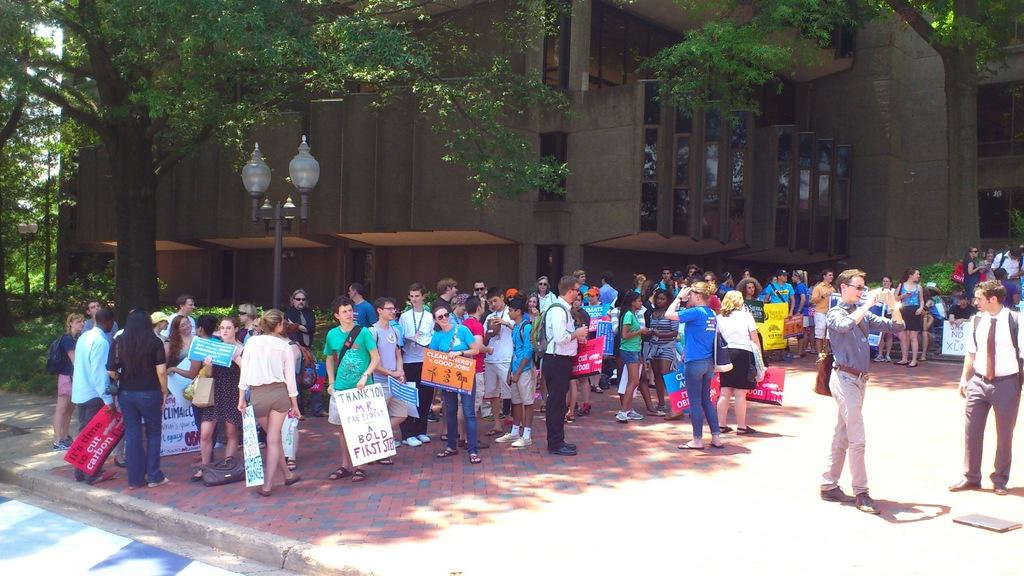What is the main subject of the image? The main subject of the image is a crowd. What are some people in the crowd doing? Some people in the crowd are holding placards. What can be seen in the image besides the crowd? There is a light pole, trees, and a building with glass windows in the background of the image. What type of lace can be seen on the building in the image? There is no lace visible on the building in the image. How many people on the committee are holding placards in the image? There is no committee mentioned in the image, and therefore it is not possible to determine how many people on the committee are holding placards. 